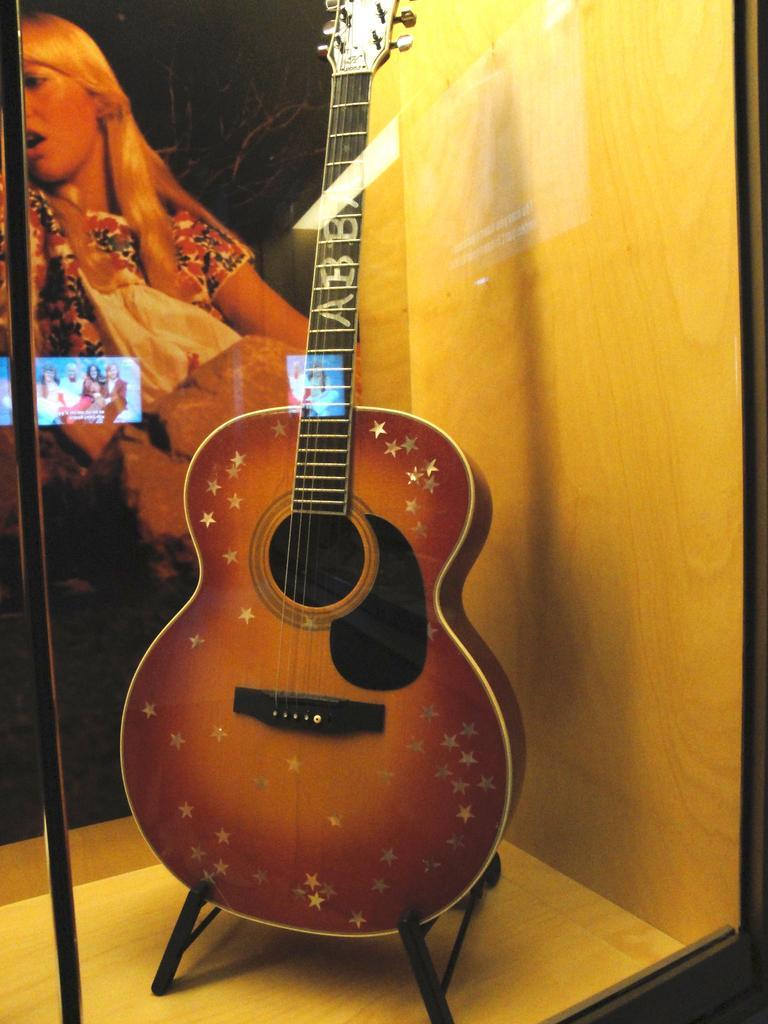How would you summarize this image in a sentence or two? A guitar is placed in a gallery. 